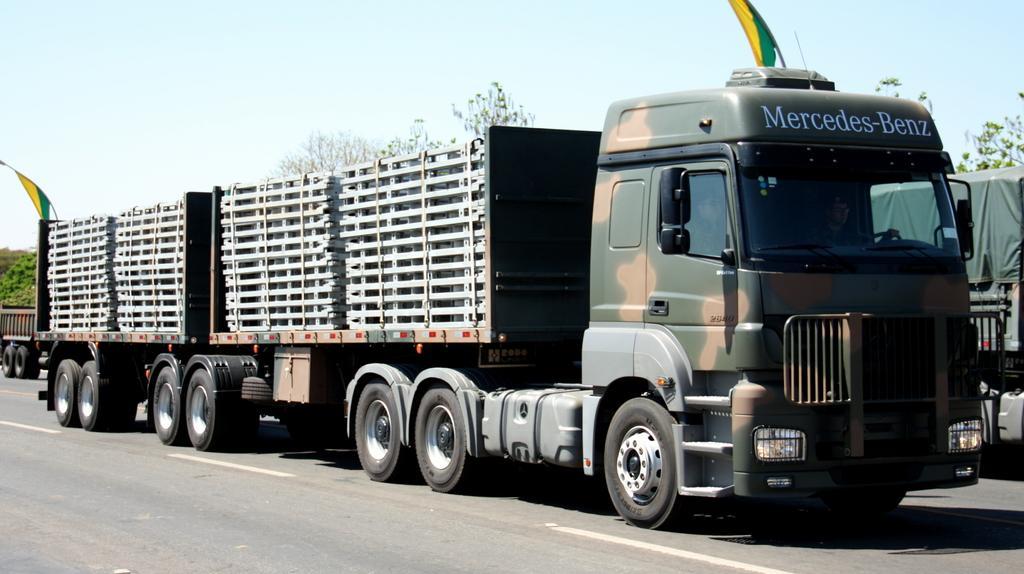Could you give a brief overview of what you see in this image? In this picture there is a green color military lorry passing on the road. Behind there are many silver color metal frames. 